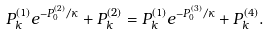Convert formula to latex. <formula><loc_0><loc_0><loc_500><loc_500>P _ { k } ^ { ( 1 ) } e ^ { - P ^ { ( 2 ) } _ { 0 } / \kappa } + P _ { k } ^ { ( 2 ) } = P _ { k } ^ { ( 1 ) } e ^ { - P ^ { ( 3 ) } _ { 0 } / \kappa } + P _ { k } ^ { ( 4 ) } .</formula> 